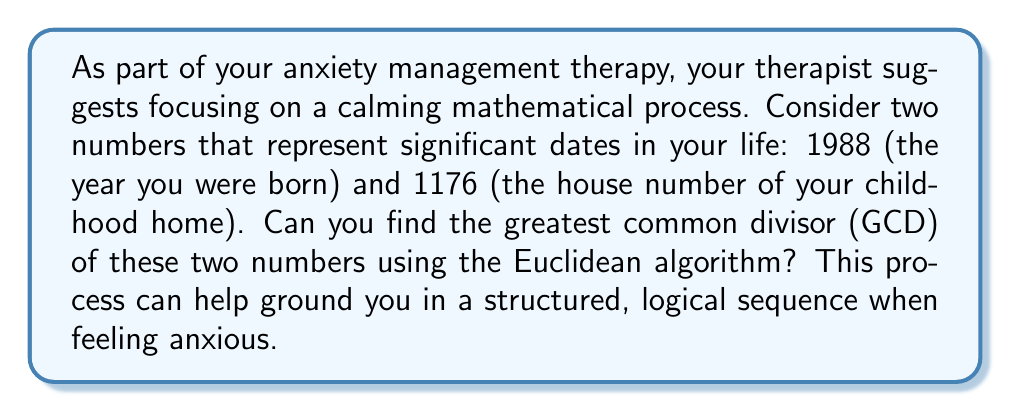Teach me how to tackle this problem. Let's apply the Euclidean algorithm to find the GCD of 1988 and 1176. This method involves repeated division until we reach a remainder of zero. Each step can be seen as a calming, methodical process:

1) First, divide 1988 by 1176:
   $1988 = 1 \times 1176 + 812$

2) Now, divide 1176 by 812:
   $1176 = 1 \times 812 + 364$

3) Divide 812 by 364:
   $812 = 2 \times 364 + 84$

4) Divide 364 by 84:
   $364 = 4 \times 84 + 28$

5) Divide 84 by 28:
   $84 = 3 \times 28 + 0$

The process stops here because we've reached a remainder of 0. The last non-zero remainder (28) is the greatest common divisor.

We can verify this result:
$1988 = 71 \times 28$
$1176 = 42 \times 28$

Indeed, 28 is the largest number that divides both 1988 and 1176 without leaving a remainder.
Answer: The greatest common divisor of 1988 and 1176 is 28. 